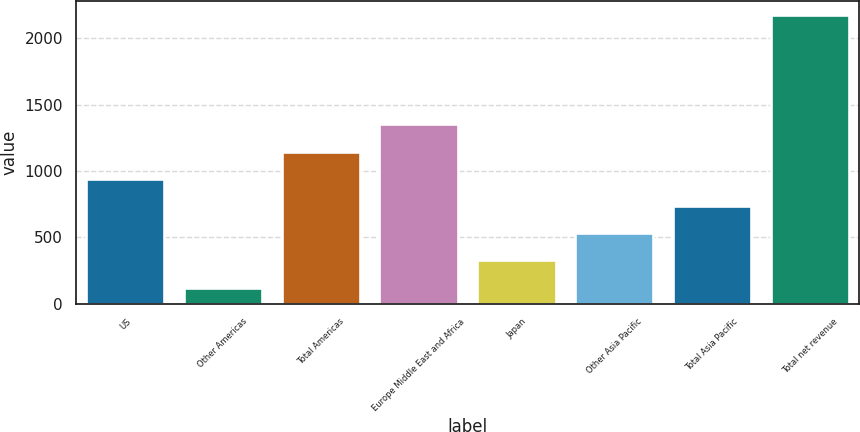Convert chart to OTSL. <chart><loc_0><loc_0><loc_500><loc_500><bar_chart><fcel>US<fcel>Other Americas<fcel>Total Americas<fcel>Europe Middle East and Africa<fcel>Japan<fcel>Other Asia Pacific<fcel>Total Asia Pacific<fcel>Total net revenue<nl><fcel>941.66<fcel>121.5<fcel>1146.7<fcel>1351.74<fcel>326.54<fcel>531.58<fcel>736.62<fcel>2171.9<nl></chart> 